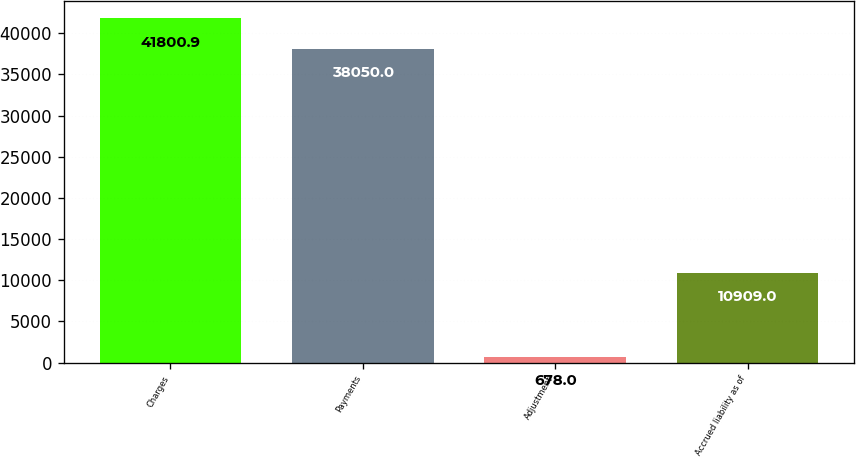<chart> <loc_0><loc_0><loc_500><loc_500><bar_chart><fcel>Charges<fcel>Payments<fcel>Adjustment<fcel>Accrued liability as of<nl><fcel>41800.9<fcel>38050<fcel>678<fcel>10909<nl></chart> 